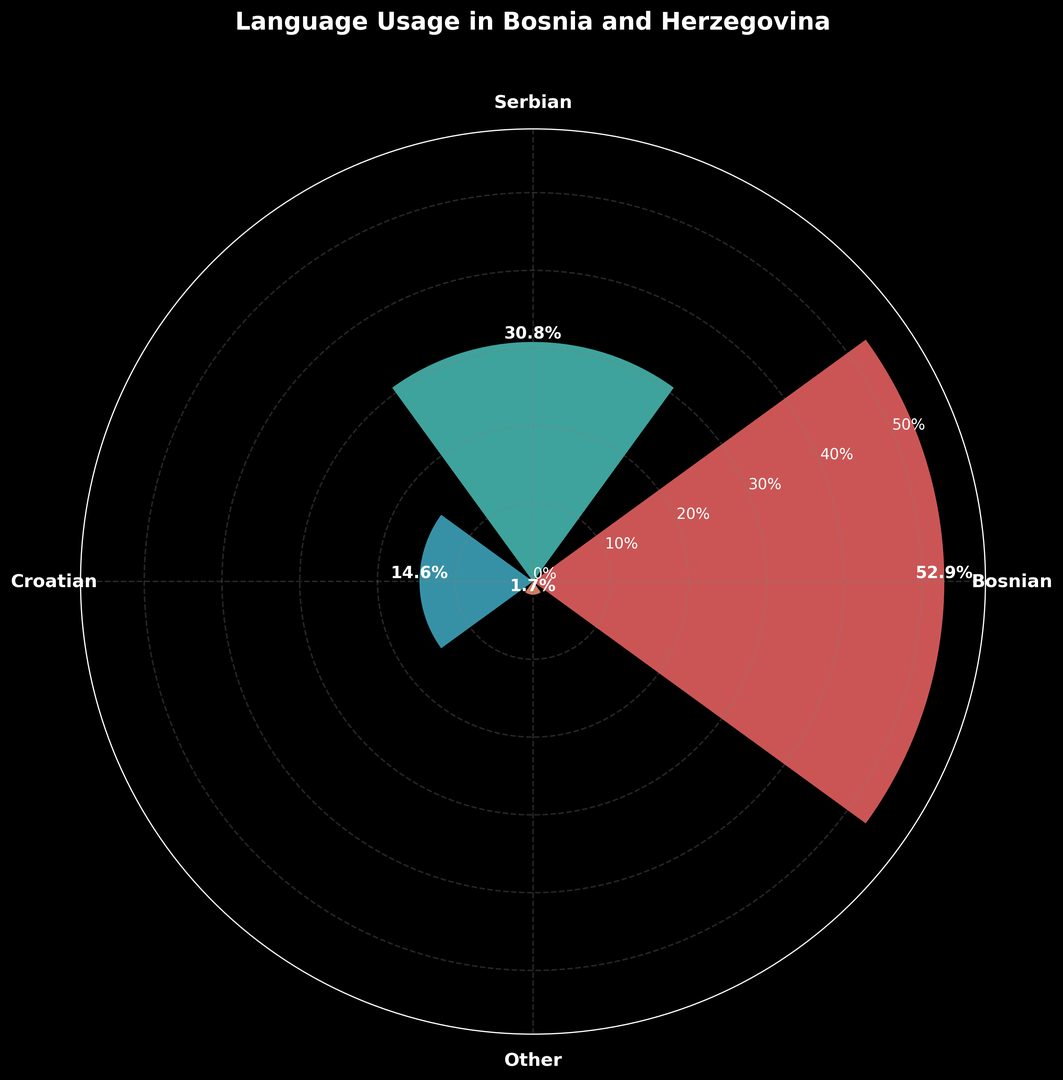What is the most spoken language in Bosnia and Herzegovina according to the chart? The chart shows that Bosnian has the highest percentage at 52.9%, which is higher than all other languages represented.
Answer: Bosnian Which language is spoken by the smallest percentage of people? The "Other" category has the smallest percentage of 1.7%, which is lower than Bosnian, Serbian, and Croatian.
Answer: Other How much more widely spoken is Bosnian compared to Croatian? Bosnian is spoken by 52.9% of people while Croatian is spoken by 14.6%. Subtract 14.6 from 52.9 to get the difference.
Answer: 38.3% What's the total percentage of people who speak Bosnian, Serbian, or Croatian? Add the percentages of Bosnian (52.9%), Serbian (30.8%), and Croatian (14.6%) to get the total.
Answer: 98.3% If you combine the percentages of "Serbian" and "Croatian", how does this new percentage compare to "Bosnian"? Adding Serbian (30.8%) and Croatian (14.6%) gives 45.4%. Compare this to Bosnian's 52.9%.
Answer: Bosnian is higher by 7.5% What percentage of people speak languages other than Bosnian, Serbian, or Croatian? Add the percentages of Bosnian (52.9%), Serbian (30.8%), and Croatian (14.6%) to get 98.3%. Subtract this sum from 100 to find out the percentage of people speaking other languages.
Answer: 1.7% Which language is depicted in green on the chart? Serbian is shown in green as per the custom color map used in the rose chart.
Answer: Serbian What is the approximate difference in height between the bar for Bosnian and the bar for Croatian? The height for Bosnian is 52.9% and for Croatian is 14.6%. Subtract 14.6 from 52.9.
Answer: 38.3% How many languages are listed in the chart? The chart shows four categories: Bosnian, Serbian, Croatian, and Other.
Answer: 4 Which language occupies the largest segment visually in the plot? The largest segment is represented by Bosnian, which has the highest percentage.
Answer: Bosnian 